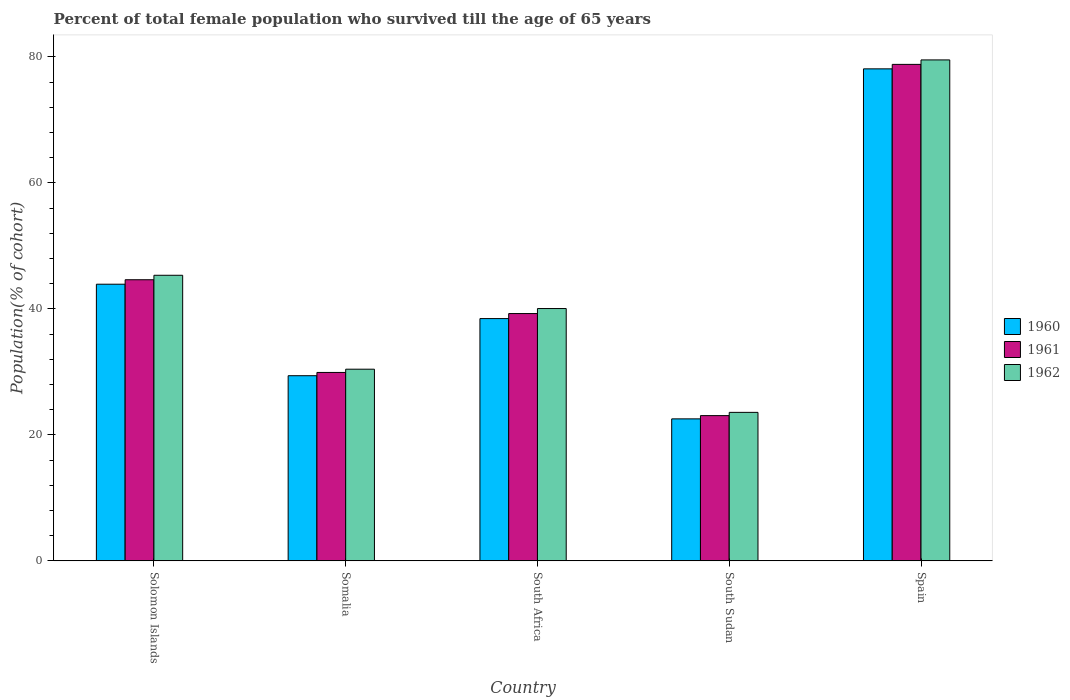How many different coloured bars are there?
Provide a short and direct response. 3. How many bars are there on the 2nd tick from the right?
Ensure brevity in your answer.  3. What is the label of the 1st group of bars from the left?
Give a very brief answer. Solomon Islands. What is the percentage of total female population who survived till the age of 65 years in 1962 in Solomon Islands?
Ensure brevity in your answer.  45.34. Across all countries, what is the maximum percentage of total female population who survived till the age of 65 years in 1961?
Offer a very short reply. 78.83. Across all countries, what is the minimum percentage of total female population who survived till the age of 65 years in 1961?
Give a very brief answer. 23.06. In which country was the percentage of total female population who survived till the age of 65 years in 1962 maximum?
Offer a terse response. Spain. In which country was the percentage of total female population who survived till the age of 65 years in 1961 minimum?
Your answer should be very brief. South Sudan. What is the total percentage of total female population who survived till the age of 65 years in 1962 in the graph?
Your answer should be compact. 218.94. What is the difference between the percentage of total female population who survived till the age of 65 years in 1962 in Solomon Islands and that in South Africa?
Your answer should be compact. 5.28. What is the difference between the percentage of total female population who survived till the age of 65 years in 1962 in Spain and the percentage of total female population who survived till the age of 65 years in 1960 in South Africa?
Provide a succinct answer. 41.07. What is the average percentage of total female population who survived till the age of 65 years in 1961 per country?
Keep it short and to the point. 43.14. What is the difference between the percentage of total female population who survived till the age of 65 years of/in 1962 and percentage of total female population who survived till the age of 65 years of/in 1960 in South Sudan?
Give a very brief answer. 1.03. What is the ratio of the percentage of total female population who survived till the age of 65 years in 1961 in Solomon Islands to that in South Sudan?
Give a very brief answer. 1.94. Is the percentage of total female population who survived till the age of 65 years in 1960 in Solomon Islands less than that in South Africa?
Make the answer very short. No. What is the difference between the highest and the second highest percentage of total female population who survived till the age of 65 years in 1961?
Your answer should be compact. -34.19. What is the difference between the highest and the lowest percentage of total female population who survived till the age of 65 years in 1961?
Your answer should be very brief. 55.77. Is the sum of the percentage of total female population who survived till the age of 65 years in 1960 in Solomon Islands and Spain greater than the maximum percentage of total female population who survived till the age of 65 years in 1962 across all countries?
Offer a very short reply. Yes. What does the 2nd bar from the right in South Africa represents?
Your response must be concise. 1961. Is it the case that in every country, the sum of the percentage of total female population who survived till the age of 65 years in 1962 and percentage of total female population who survived till the age of 65 years in 1961 is greater than the percentage of total female population who survived till the age of 65 years in 1960?
Offer a very short reply. Yes. How many bars are there?
Provide a succinct answer. 15. How many countries are there in the graph?
Your answer should be compact. 5. Does the graph contain grids?
Offer a terse response. No. How are the legend labels stacked?
Give a very brief answer. Vertical. What is the title of the graph?
Provide a succinct answer. Percent of total female population who survived till the age of 65 years. What is the label or title of the Y-axis?
Offer a terse response. Population(% of cohort). What is the Population(% of cohort) in 1960 in Solomon Islands?
Give a very brief answer. 43.92. What is the Population(% of cohort) of 1961 in Solomon Islands?
Your response must be concise. 44.63. What is the Population(% of cohort) in 1962 in Solomon Islands?
Make the answer very short. 45.34. What is the Population(% of cohort) of 1960 in Somalia?
Offer a very short reply. 29.39. What is the Population(% of cohort) in 1961 in Somalia?
Offer a terse response. 29.91. What is the Population(% of cohort) in 1962 in Somalia?
Provide a succinct answer. 30.43. What is the Population(% of cohort) of 1960 in South Africa?
Your answer should be very brief. 38.46. What is the Population(% of cohort) of 1961 in South Africa?
Make the answer very short. 39.26. What is the Population(% of cohort) of 1962 in South Africa?
Your answer should be compact. 40.06. What is the Population(% of cohort) in 1960 in South Sudan?
Your response must be concise. 22.54. What is the Population(% of cohort) in 1961 in South Sudan?
Offer a very short reply. 23.06. What is the Population(% of cohort) in 1962 in South Sudan?
Your answer should be very brief. 23.57. What is the Population(% of cohort) of 1960 in Spain?
Your answer should be compact. 78.12. What is the Population(% of cohort) in 1961 in Spain?
Offer a very short reply. 78.83. What is the Population(% of cohort) in 1962 in Spain?
Your answer should be compact. 79.53. Across all countries, what is the maximum Population(% of cohort) of 1960?
Your answer should be compact. 78.12. Across all countries, what is the maximum Population(% of cohort) in 1961?
Make the answer very short. 78.83. Across all countries, what is the maximum Population(% of cohort) of 1962?
Ensure brevity in your answer.  79.53. Across all countries, what is the minimum Population(% of cohort) of 1960?
Provide a short and direct response. 22.54. Across all countries, what is the minimum Population(% of cohort) of 1961?
Provide a succinct answer. 23.06. Across all countries, what is the minimum Population(% of cohort) of 1962?
Your answer should be compact. 23.57. What is the total Population(% of cohort) of 1960 in the graph?
Keep it short and to the point. 212.43. What is the total Population(% of cohort) of 1961 in the graph?
Provide a short and direct response. 215.69. What is the total Population(% of cohort) in 1962 in the graph?
Ensure brevity in your answer.  218.94. What is the difference between the Population(% of cohort) in 1960 in Solomon Islands and that in Somalia?
Make the answer very short. 14.53. What is the difference between the Population(% of cohort) in 1961 in Solomon Islands and that in Somalia?
Make the answer very short. 14.72. What is the difference between the Population(% of cohort) of 1962 in Solomon Islands and that in Somalia?
Give a very brief answer. 14.91. What is the difference between the Population(% of cohort) of 1960 in Solomon Islands and that in South Africa?
Make the answer very short. 5.46. What is the difference between the Population(% of cohort) of 1961 in Solomon Islands and that in South Africa?
Ensure brevity in your answer.  5.37. What is the difference between the Population(% of cohort) of 1962 in Solomon Islands and that in South Africa?
Your answer should be very brief. 5.28. What is the difference between the Population(% of cohort) in 1960 in Solomon Islands and that in South Sudan?
Keep it short and to the point. 21.38. What is the difference between the Population(% of cohort) of 1961 in Solomon Islands and that in South Sudan?
Keep it short and to the point. 21.58. What is the difference between the Population(% of cohort) in 1962 in Solomon Islands and that in South Sudan?
Your answer should be compact. 21.77. What is the difference between the Population(% of cohort) in 1960 in Solomon Islands and that in Spain?
Your answer should be very brief. -34.19. What is the difference between the Population(% of cohort) of 1961 in Solomon Islands and that in Spain?
Keep it short and to the point. -34.19. What is the difference between the Population(% of cohort) in 1962 in Solomon Islands and that in Spain?
Give a very brief answer. -34.19. What is the difference between the Population(% of cohort) of 1960 in Somalia and that in South Africa?
Your answer should be compact. -9.07. What is the difference between the Population(% of cohort) in 1961 in Somalia and that in South Africa?
Offer a very short reply. -9.35. What is the difference between the Population(% of cohort) of 1962 in Somalia and that in South Africa?
Offer a very short reply. -9.63. What is the difference between the Population(% of cohort) of 1960 in Somalia and that in South Sudan?
Provide a succinct answer. 6.85. What is the difference between the Population(% of cohort) of 1961 in Somalia and that in South Sudan?
Your answer should be compact. 6.85. What is the difference between the Population(% of cohort) of 1962 in Somalia and that in South Sudan?
Provide a succinct answer. 6.86. What is the difference between the Population(% of cohort) in 1960 in Somalia and that in Spain?
Provide a short and direct response. -48.72. What is the difference between the Population(% of cohort) of 1961 in Somalia and that in Spain?
Make the answer very short. -48.91. What is the difference between the Population(% of cohort) in 1962 in Somalia and that in Spain?
Your answer should be compact. -49.11. What is the difference between the Population(% of cohort) in 1960 in South Africa and that in South Sudan?
Give a very brief answer. 15.92. What is the difference between the Population(% of cohort) of 1961 in South Africa and that in South Sudan?
Offer a terse response. 16.2. What is the difference between the Population(% of cohort) in 1962 in South Africa and that in South Sudan?
Offer a very short reply. 16.49. What is the difference between the Population(% of cohort) of 1960 in South Africa and that in Spain?
Offer a very short reply. -39.65. What is the difference between the Population(% of cohort) of 1961 in South Africa and that in Spain?
Keep it short and to the point. -39.56. What is the difference between the Population(% of cohort) of 1962 in South Africa and that in Spain?
Ensure brevity in your answer.  -39.47. What is the difference between the Population(% of cohort) of 1960 in South Sudan and that in Spain?
Provide a succinct answer. -55.58. What is the difference between the Population(% of cohort) in 1961 in South Sudan and that in Spain?
Your response must be concise. -55.77. What is the difference between the Population(% of cohort) of 1962 in South Sudan and that in Spain?
Provide a short and direct response. -55.96. What is the difference between the Population(% of cohort) of 1960 in Solomon Islands and the Population(% of cohort) of 1961 in Somalia?
Your answer should be compact. 14.01. What is the difference between the Population(% of cohort) in 1960 in Solomon Islands and the Population(% of cohort) in 1962 in Somalia?
Offer a very short reply. 13.49. What is the difference between the Population(% of cohort) of 1961 in Solomon Islands and the Population(% of cohort) of 1962 in Somalia?
Offer a very short reply. 14.2. What is the difference between the Population(% of cohort) of 1960 in Solomon Islands and the Population(% of cohort) of 1961 in South Africa?
Offer a very short reply. 4.66. What is the difference between the Population(% of cohort) of 1960 in Solomon Islands and the Population(% of cohort) of 1962 in South Africa?
Give a very brief answer. 3.86. What is the difference between the Population(% of cohort) in 1961 in Solomon Islands and the Population(% of cohort) in 1962 in South Africa?
Give a very brief answer. 4.57. What is the difference between the Population(% of cohort) in 1960 in Solomon Islands and the Population(% of cohort) in 1961 in South Sudan?
Make the answer very short. 20.87. What is the difference between the Population(% of cohort) in 1960 in Solomon Islands and the Population(% of cohort) in 1962 in South Sudan?
Provide a succinct answer. 20.35. What is the difference between the Population(% of cohort) in 1961 in Solomon Islands and the Population(% of cohort) in 1962 in South Sudan?
Keep it short and to the point. 21.06. What is the difference between the Population(% of cohort) in 1960 in Solomon Islands and the Population(% of cohort) in 1961 in Spain?
Provide a short and direct response. -34.9. What is the difference between the Population(% of cohort) of 1960 in Solomon Islands and the Population(% of cohort) of 1962 in Spain?
Your answer should be very brief. -35.61. What is the difference between the Population(% of cohort) of 1961 in Solomon Islands and the Population(% of cohort) of 1962 in Spain?
Give a very brief answer. -34.9. What is the difference between the Population(% of cohort) in 1960 in Somalia and the Population(% of cohort) in 1961 in South Africa?
Ensure brevity in your answer.  -9.87. What is the difference between the Population(% of cohort) of 1960 in Somalia and the Population(% of cohort) of 1962 in South Africa?
Offer a very short reply. -10.67. What is the difference between the Population(% of cohort) in 1961 in Somalia and the Population(% of cohort) in 1962 in South Africa?
Provide a succinct answer. -10.15. What is the difference between the Population(% of cohort) in 1960 in Somalia and the Population(% of cohort) in 1961 in South Sudan?
Provide a short and direct response. 6.34. What is the difference between the Population(% of cohort) of 1960 in Somalia and the Population(% of cohort) of 1962 in South Sudan?
Provide a succinct answer. 5.82. What is the difference between the Population(% of cohort) in 1961 in Somalia and the Population(% of cohort) in 1962 in South Sudan?
Give a very brief answer. 6.34. What is the difference between the Population(% of cohort) in 1960 in Somalia and the Population(% of cohort) in 1961 in Spain?
Ensure brevity in your answer.  -49.43. What is the difference between the Population(% of cohort) of 1960 in Somalia and the Population(% of cohort) of 1962 in Spain?
Offer a terse response. -50.14. What is the difference between the Population(% of cohort) of 1961 in Somalia and the Population(% of cohort) of 1962 in Spain?
Keep it short and to the point. -49.62. What is the difference between the Population(% of cohort) of 1960 in South Africa and the Population(% of cohort) of 1961 in South Sudan?
Your answer should be compact. 15.41. What is the difference between the Population(% of cohort) in 1960 in South Africa and the Population(% of cohort) in 1962 in South Sudan?
Give a very brief answer. 14.89. What is the difference between the Population(% of cohort) of 1961 in South Africa and the Population(% of cohort) of 1962 in South Sudan?
Provide a succinct answer. 15.69. What is the difference between the Population(% of cohort) in 1960 in South Africa and the Population(% of cohort) in 1961 in Spain?
Your answer should be very brief. -40.36. What is the difference between the Population(% of cohort) in 1960 in South Africa and the Population(% of cohort) in 1962 in Spain?
Keep it short and to the point. -41.07. What is the difference between the Population(% of cohort) in 1961 in South Africa and the Population(% of cohort) in 1962 in Spain?
Offer a very short reply. -40.27. What is the difference between the Population(% of cohort) in 1960 in South Sudan and the Population(% of cohort) in 1961 in Spain?
Ensure brevity in your answer.  -56.29. What is the difference between the Population(% of cohort) in 1960 in South Sudan and the Population(% of cohort) in 1962 in Spain?
Give a very brief answer. -56.99. What is the difference between the Population(% of cohort) in 1961 in South Sudan and the Population(% of cohort) in 1962 in Spain?
Provide a short and direct response. -56.48. What is the average Population(% of cohort) of 1960 per country?
Keep it short and to the point. 42.49. What is the average Population(% of cohort) in 1961 per country?
Provide a short and direct response. 43.14. What is the average Population(% of cohort) in 1962 per country?
Make the answer very short. 43.79. What is the difference between the Population(% of cohort) of 1960 and Population(% of cohort) of 1961 in Solomon Islands?
Provide a succinct answer. -0.71. What is the difference between the Population(% of cohort) of 1960 and Population(% of cohort) of 1962 in Solomon Islands?
Offer a very short reply. -1.42. What is the difference between the Population(% of cohort) of 1961 and Population(% of cohort) of 1962 in Solomon Islands?
Give a very brief answer. -0.71. What is the difference between the Population(% of cohort) in 1960 and Population(% of cohort) in 1961 in Somalia?
Give a very brief answer. -0.52. What is the difference between the Population(% of cohort) in 1960 and Population(% of cohort) in 1962 in Somalia?
Provide a short and direct response. -1.04. What is the difference between the Population(% of cohort) in 1961 and Population(% of cohort) in 1962 in Somalia?
Provide a succinct answer. -0.52. What is the difference between the Population(% of cohort) of 1960 and Population(% of cohort) of 1961 in South Africa?
Keep it short and to the point. -0.8. What is the difference between the Population(% of cohort) of 1960 and Population(% of cohort) of 1962 in South Africa?
Keep it short and to the point. -1.6. What is the difference between the Population(% of cohort) in 1961 and Population(% of cohort) in 1962 in South Africa?
Your response must be concise. -0.8. What is the difference between the Population(% of cohort) of 1960 and Population(% of cohort) of 1961 in South Sudan?
Make the answer very short. -0.52. What is the difference between the Population(% of cohort) in 1960 and Population(% of cohort) in 1962 in South Sudan?
Ensure brevity in your answer.  -1.03. What is the difference between the Population(% of cohort) of 1961 and Population(% of cohort) of 1962 in South Sudan?
Offer a very short reply. -0.52. What is the difference between the Population(% of cohort) of 1960 and Population(% of cohort) of 1961 in Spain?
Ensure brevity in your answer.  -0.71. What is the difference between the Population(% of cohort) in 1960 and Population(% of cohort) in 1962 in Spain?
Provide a short and direct response. -1.42. What is the difference between the Population(% of cohort) of 1961 and Population(% of cohort) of 1962 in Spain?
Make the answer very short. -0.71. What is the ratio of the Population(% of cohort) of 1960 in Solomon Islands to that in Somalia?
Make the answer very short. 1.49. What is the ratio of the Population(% of cohort) in 1961 in Solomon Islands to that in Somalia?
Provide a succinct answer. 1.49. What is the ratio of the Population(% of cohort) of 1962 in Solomon Islands to that in Somalia?
Give a very brief answer. 1.49. What is the ratio of the Population(% of cohort) of 1960 in Solomon Islands to that in South Africa?
Provide a short and direct response. 1.14. What is the ratio of the Population(% of cohort) of 1961 in Solomon Islands to that in South Africa?
Keep it short and to the point. 1.14. What is the ratio of the Population(% of cohort) in 1962 in Solomon Islands to that in South Africa?
Make the answer very short. 1.13. What is the ratio of the Population(% of cohort) in 1960 in Solomon Islands to that in South Sudan?
Keep it short and to the point. 1.95. What is the ratio of the Population(% of cohort) of 1961 in Solomon Islands to that in South Sudan?
Make the answer very short. 1.94. What is the ratio of the Population(% of cohort) of 1962 in Solomon Islands to that in South Sudan?
Make the answer very short. 1.92. What is the ratio of the Population(% of cohort) in 1960 in Solomon Islands to that in Spain?
Provide a succinct answer. 0.56. What is the ratio of the Population(% of cohort) in 1961 in Solomon Islands to that in Spain?
Your response must be concise. 0.57. What is the ratio of the Population(% of cohort) in 1962 in Solomon Islands to that in Spain?
Your response must be concise. 0.57. What is the ratio of the Population(% of cohort) of 1960 in Somalia to that in South Africa?
Your answer should be compact. 0.76. What is the ratio of the Population(% of cohort) of 1961 in Somalia to that in South Africa?
Ensure brevity in your answer.  0.76. What is the ratio of the Population(% of cohort) of 1962 in Somalia to that in South Africa?
Provide a short and direct response. 0.76. What is the ratio of the Population(% of cohort) of 1960 in Somalia to that in South Sudan?
Offer a terse response. 1.3. What is the ratio of the Population(% of cohort) of 1961 in Somalia to that in South Sudan?
Make the answer very short. 1.3. What is the ratio of the Population(% of cohort) of 1962 in Somalia to that in South Sudan?
Your response must be concise. 1.29. What is the ratio of the Population(% of cohort) of 1960 in Somalia to that in Spain?
Provide a short and direct response. 0.38. What is the ratio of the Population(% of cohort) of 1961 in Somalia to that in Spain?
Provide a short and direct response. 0.38. What is the ratio of the Population(% of cohort) in 1962 in Somalia to that in Spain?
Provide a succinct answer. 0.38. What is the ratio of the Population(% of cohort) of 1960 in South Africa to that in South Sudan?
Your response must be concise. 1.71. What is the ratio of the Population(% of cohort) of 1961 in South Africa to that in South Sudan?
Your answer should be compact. 1.7. What is the ratio of the Population(% of cohort) of 1962 in South Africa to that in South Sudan?
Offer a very short reply. 1.7. What is the ratio of the Population(% of cohort) of 1960 in South Africa to that in Spain?
Your response must be concise. 0.49. What is the ratio of the Population(% of cohort) of 1961 in South Africa to that in Spain?
Make the answer very short. 0.5. What is the ratio of the Population(% of cohort) in 1962 in South Africa to that in Spain?
Provide a succinct answer. 0.5. What is the ratio of the Population(% of cohort) in 1960 in South Sudan to that in Spain?
Make the answer very short. 0.29. What is the ratio of the Population(% of cohort) of 1961 in South Sudan to that in Spain?
Ensure brevity in your answer.  0.29. What is the ratio of the Population(% of cohort) of 1962 in South Sudan to that in Spain?
Provide a short and direct response. 0.3. What is the difference between the highest and the second highest Population(% of cohort) of 1960?
Make the answer very short. 34.19. What is the difference between the highest and the second highest Population(% of cohort) in 1961?
Make the answer very short. 34.19. What is the difference between the highest and the second highest Population(% of cohort) of 1962?
Ensure brevity in your answer.  34.19. What is the difference between the highest and the lowest Population(% of cohort) in 1960?
Provide a succinct answer. 55.58. What is the difference between the highest and the lowest Population(% of cohort) in 1961?
Your response must be concise. 55.77. What is the difference between the highest and the lowest Population(% of cohort) of 1962?
Your answer should be very brief. 55.96. 